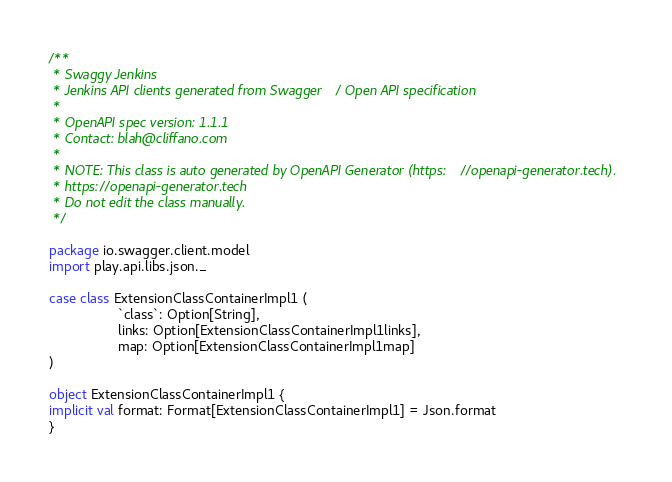Convert code to text. <code><loc_0><loc_0><loc_500><loc_500><_Scala_>/**
 * Swaggy Jenkins
 * Jenkins API clients generated from Swagger / Open API specification
 *
 * OpenAPI spec version: 1.1.1
 * Contact: blah@cliffano.com
 *
 * NOTE: This class is auto generated by OpenAPI Generator (https://openapi-generator.tech).
 * https://openapi-generator.tech
 * Do not edit the class manually.
 */

package io.swagger.client.model
import play.api.libs.json._

case class ExtensionClassContainerImpl1 (
                  `class`: Option[String],
                  links: Option[ExtensionClassContainerImpl1links],
                  map: Option[ExtensionClassContainerImpl1map]
)

object ExtensionClassContainerImpl1 {
implicit val format: Format[ExtensionClassContainerImpl1] = Json.format
}

</code> 